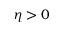Convert formula to latex. <formula><loc_0><loc_0><loc_500><loc_500>\eta > 0</formula> 